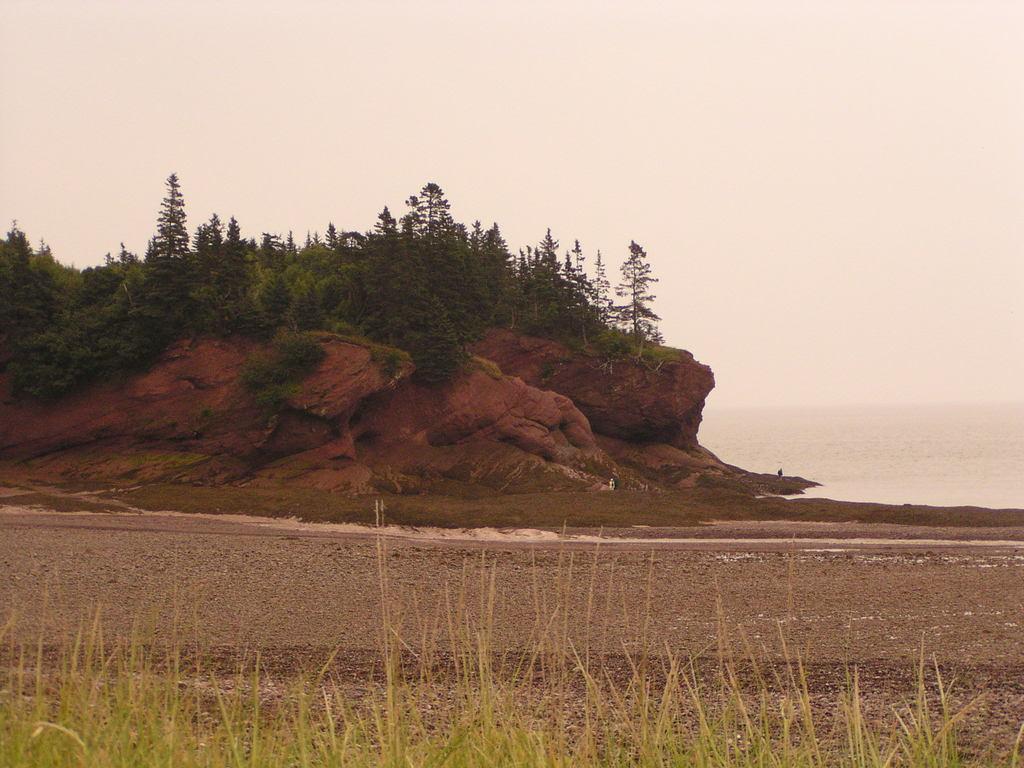In one or two sentences, can you explain what this image depicts? In this image there is a big rock on which there are plants. At the bottom there is sand on which there is grass. At the top there is sky. 